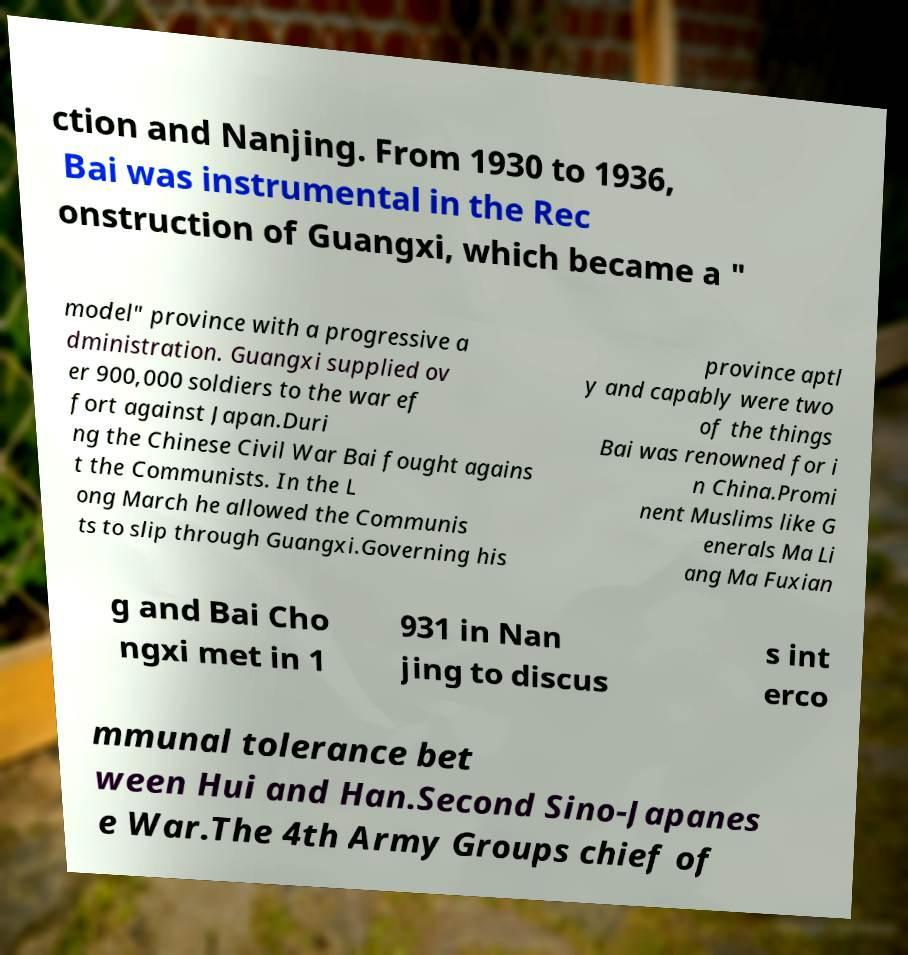Could you extract and type out the text from this image? ction and Nanjing. From 1930 to 1936, Bai was instrumental in the Rec onstruction of Guangxi, which became a " model" province with a progressive a dministration. Guangxi supplied ov er 900,000 soldiers to the war ef fort against Japan.Duri ng the Chinese Civil War Bai fought agains t the Communists. In the L ong March he allowed the Communis ts to slip through Guangxi.Governing his province aptl y and capably were two of the things Bai was renowned for i n China.Promi nent Muslims like G enerals Ma Li ang Ma Fuxian g and Bai Cho ngxi met in 1 931 in Nan jing to discus s int erco mmunal tolerance bet ween Hui and Han.Second Sino-Japanes e War.The 4th Army Groups chief of 